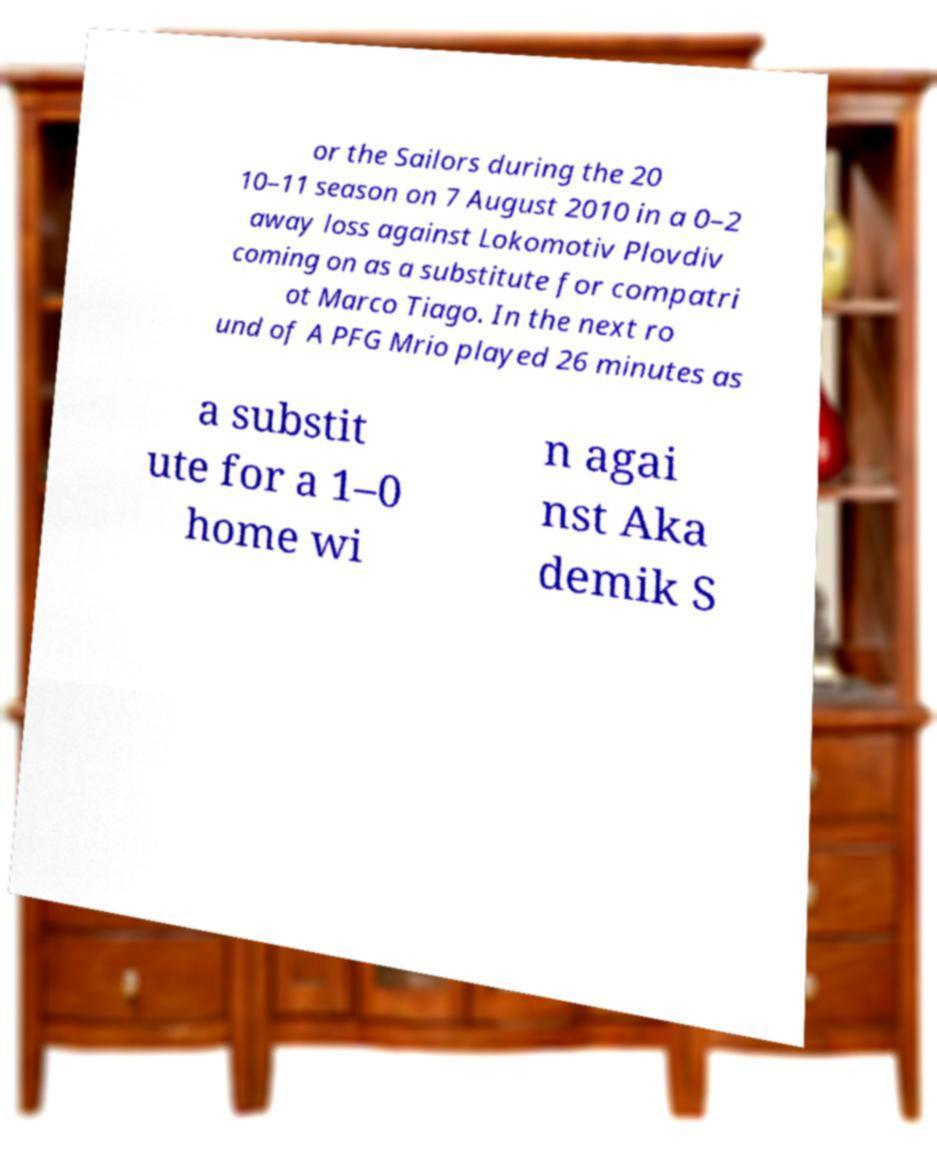Can you read and provide the text displayed in the image?This photo seems to have some interesting text. Can you extract and type it out for me? or the Sailors during the 20 10–11 season on 7 August 2010 in a 0–2 away loss against Lokomotiv Plovdiv coming on as a substitute for compatri ot Marco Tiago. In the next ro und of A PFG Mrio played 26 minutes as a substit ute for a 1–0 home wi n agai nst Aka demik S 